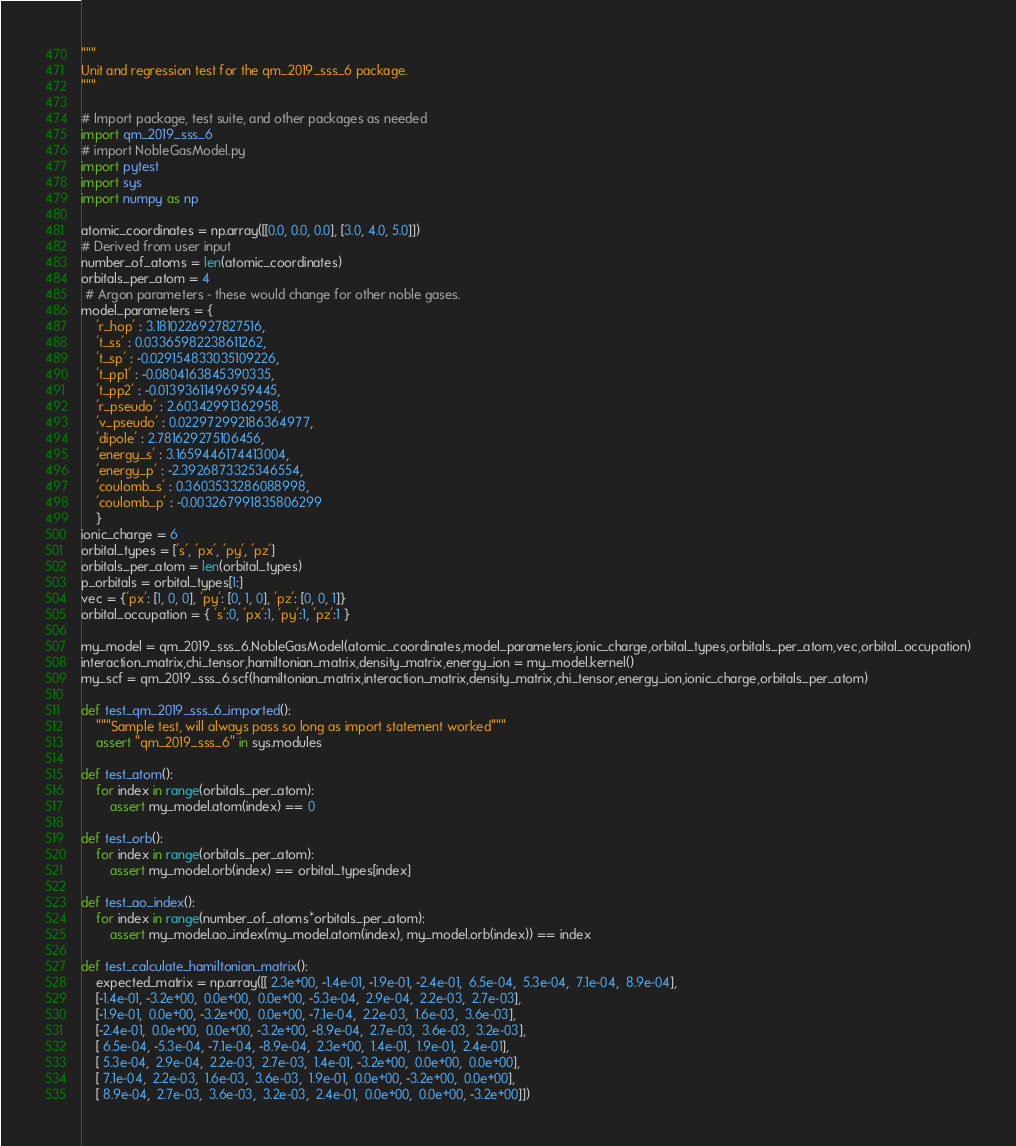Convert code to text. <code><loc_0><loc_0><loc_500><loc_500><_Python_>"""
Unit and regression test for the qm_2019_sss_6 package.
"""

# Import package, test suite, and other packages as needed
import qm_2019_sss_6
# import NobleGasModel.py
import pytest
import sys
import numpy as np

atomic_coordinates = np.array([[0.0, 0.0, 0.0], [3.0, 4.0, 5.0]])
# Derived from user input
number_of_atoms = len(atomic_coordinates)
orbitals_per_atom = 4
 # Argon parameters - these would change for other noble gases.
model_parameters = {
    'r_hop' : 3.1810226927827516,
    't_ss' : 0.03365982238611262,
    't_sp' : -0.029154833035109226,
    't_pp1' : -0.0804163845390335,
    't_pp2' : -0.01393611496959445,
    'r_pseudo' : 2.60342991362958,
    'v_pseudo' : 0.022972992186364977,
    'dipole' : 2.781629275106456,
    'energy_s' : 3.1659446174413004,
    'energy_p' : -2.3926873325346554,
    'coulomb_s' : 0.3603533286088998,
    'coulomb_p' : -0.003267991835806299
    }
ionic_charge = 6
orbital_types = ['s', 'px', 'py', 'pz']
orbitals_per_atom = len(orbital_types)
p_orbitals = orbital_types[1:]
vec = {'px': [1, 0, 0], 'py': [0, 1, 0], 'pz': [0, 0, 1]}
orbital_occupation = { 's':0, 'px':1, 'py':1, 'pz':1 }

my_model = qm_2019_sss_6.NobleGasModel(atomic_coordinates,model_parameters,ionic_charge,orbital_types,orbitals_per_atom,vec,orbital_occupation)
interaction_matrix,chi_tensor,hamiltonian_matrix,density_matrix,energy_ion = my_model.kernel()
my_scf = qm_2019_sss_6.scf(hamiltonian_matrix,interaction_matrix,density_matrix,chi_tensor,energy_ion,ionic_charge,orbitals_per_atom)

def test_qm_2019_sss_6_imported():
    """Sample test, will always pass so long as import statement worked"""
    assert "qm_2019_sss_6" in sys.modules

def test_atom():
    for index in range(orbitals_per_atom):
        assert my_model.atom(index) == 0

def test_orb():
    for index in range(orbitals_per_atom):
        assert my_model.orb(index) == orbital_types[index]

def test_ao_index():
    for index in range(number_of_atoms*orbitals_per_atom):
        assert my_model.ao_index(my_model.atom(index), my_model.orb(index)) == index

def test_calculate_hamiltonian_matrix():
    expected_matrix = np.array([[ 2.3e+00, -1.4e-01, -1.9e-01, -2.4e-01,  6.5e-04,  5.3e-04,  7.1e-04,  8.9e-04],
    [-1.4e-01, -3.2e+00,  0.0e+00,  0.0e+00, -5.3e-04,  2.9e-04,  2.2e-03,  2.7e-03],
    [-1.9e-01,  0.0e+00, -3.2e+00,  0.0e+00, -7.1e-04,  2.2e-03,  1.6e-03,  3.6e-03],
    [-2.4e-01,  0.0e+00,  0.0e+00, -3.2e+00, -8.9e-04,  2.7e-03,  3.6e-03,  3.2e-03],
    [ 6.5e-04, -5.3e-04, -7.1e-04, -8.9e-04,  2.3e+00,  1.4e-01,  1.9e-01,  2.4e-01],
    [ 5.3e-04,  2.9e-04,  2.2e-03,  2.7e-03,  1.4e-01, -3.2e+00,  0.0e+00,  0.0e+00],
    [ 7.1e-04,  2.2e-03,  1.6e-03,  3.6e-03,  1.9e-01,  0.0e+00, -3.2e+00,  0.0e+00],
    [ 8.9e-04,  2.7e-03,  3.6e-03,  3.2e-03,  2.4e-01,  0.0e+00,  0.0e+00, -3.2e+00]])
</code> 